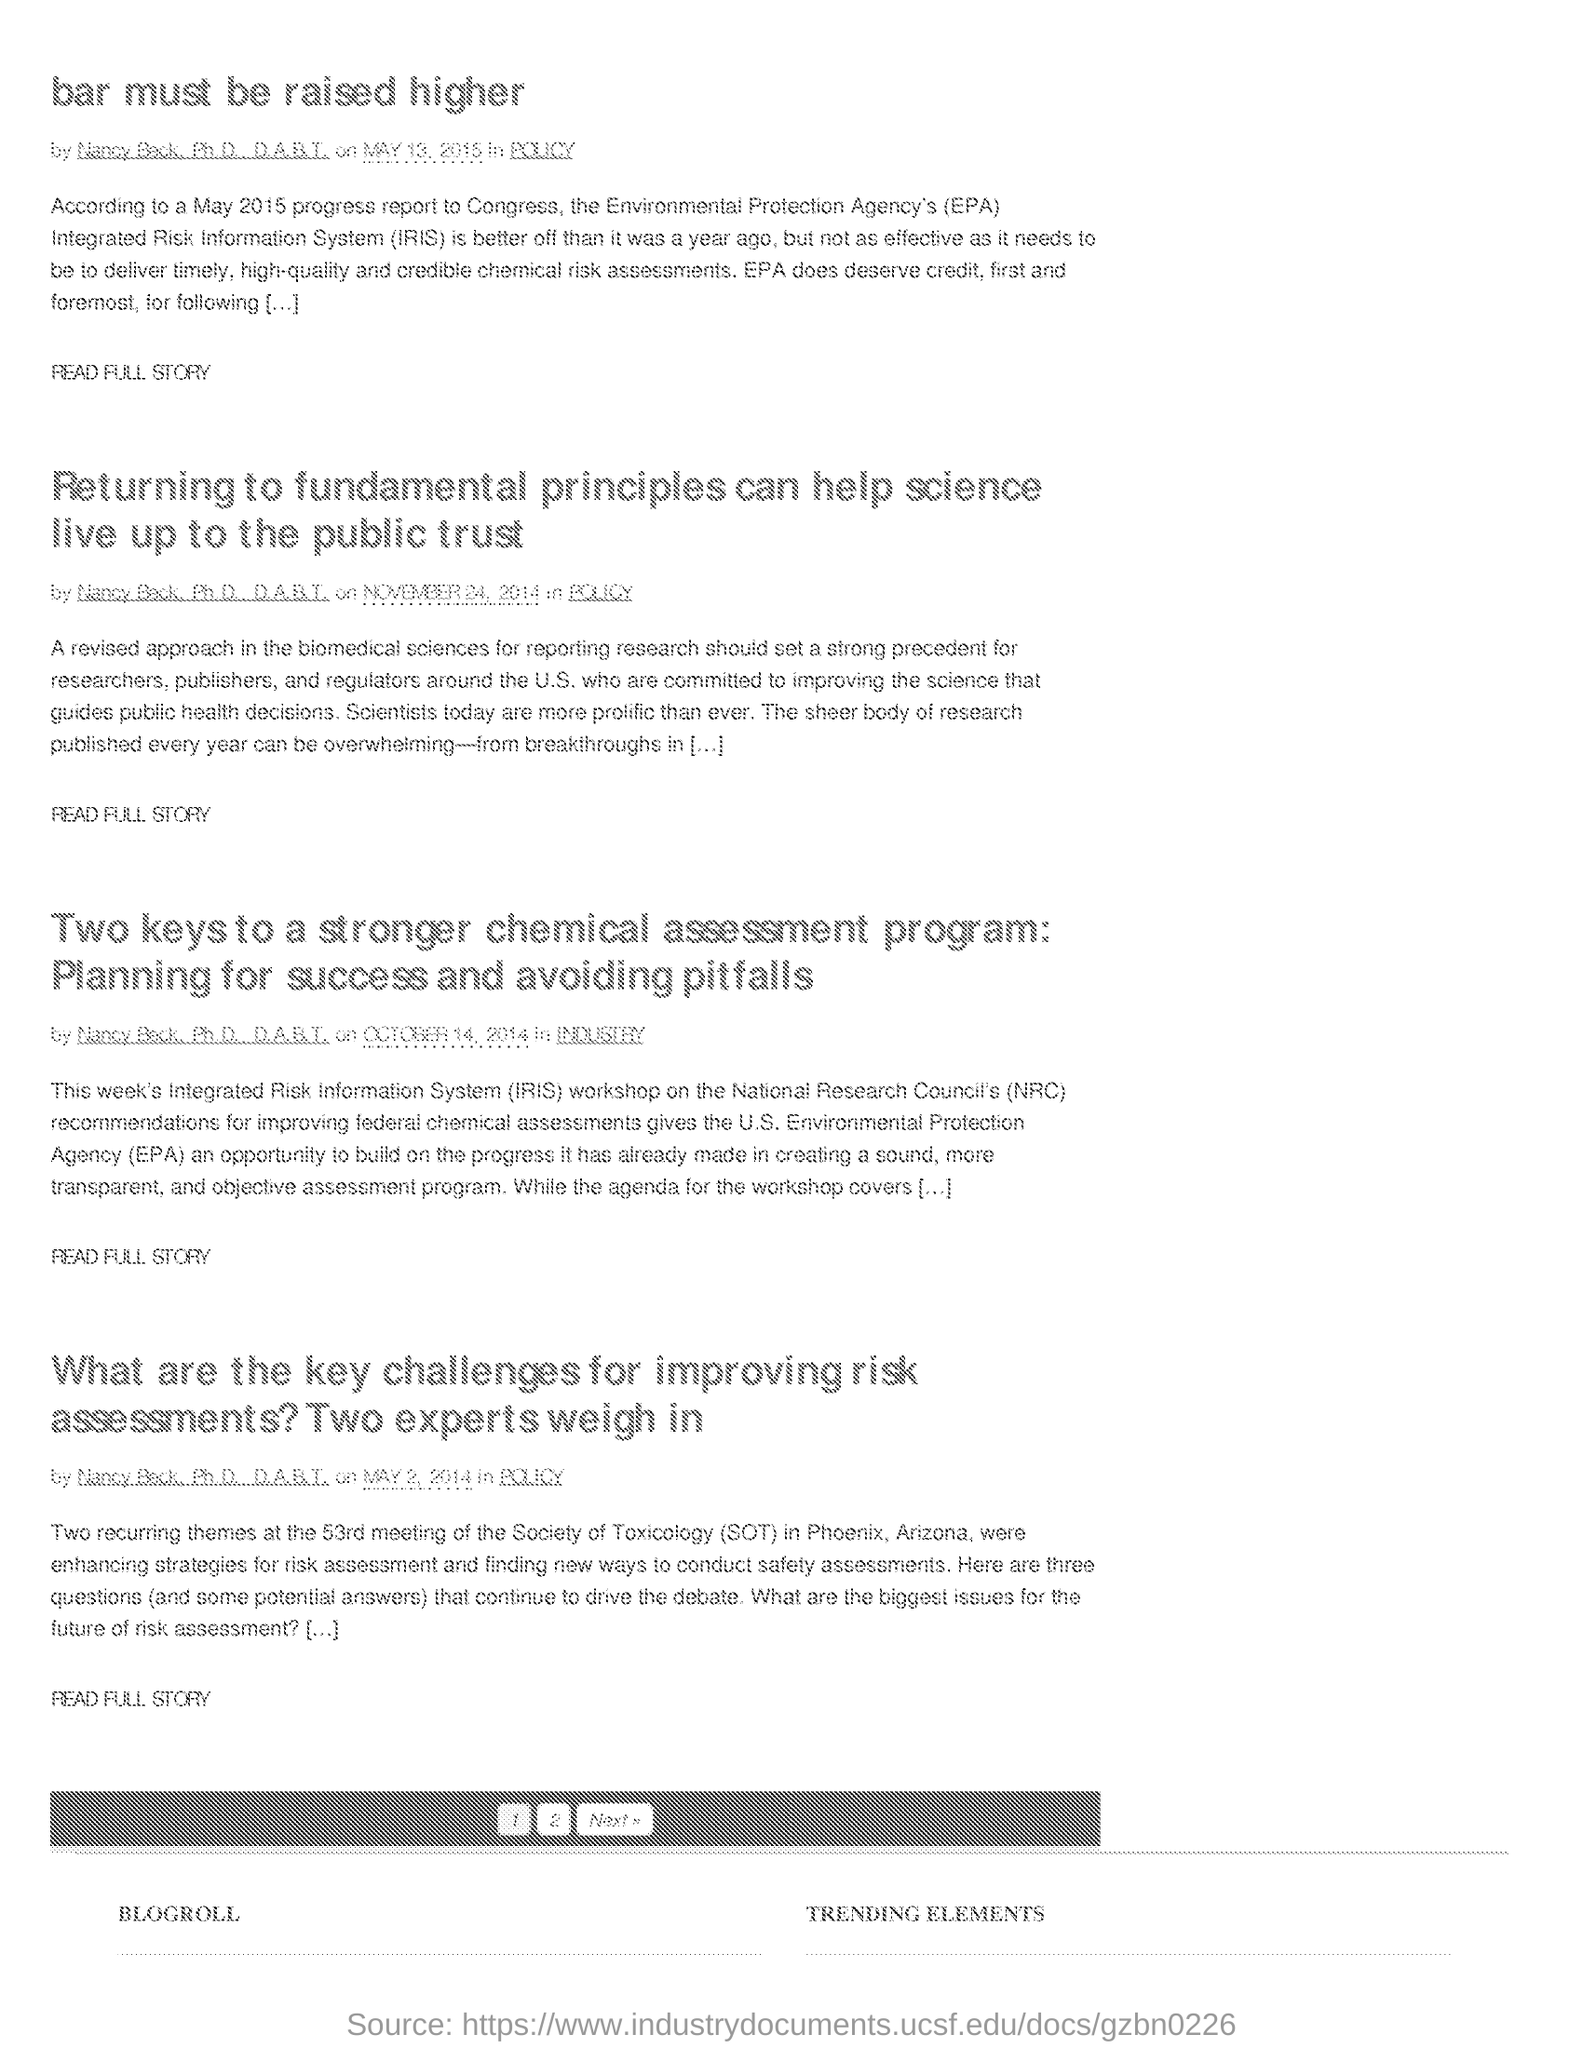What does IRIS stand for?
Keep it short and to the point. INTEGRATED RISK INFORMATION SYSTEM. Where was the 53rd meeting of the Society of Toxicology held?
Your response must be concise. PHOENIX, ARIZONA. 